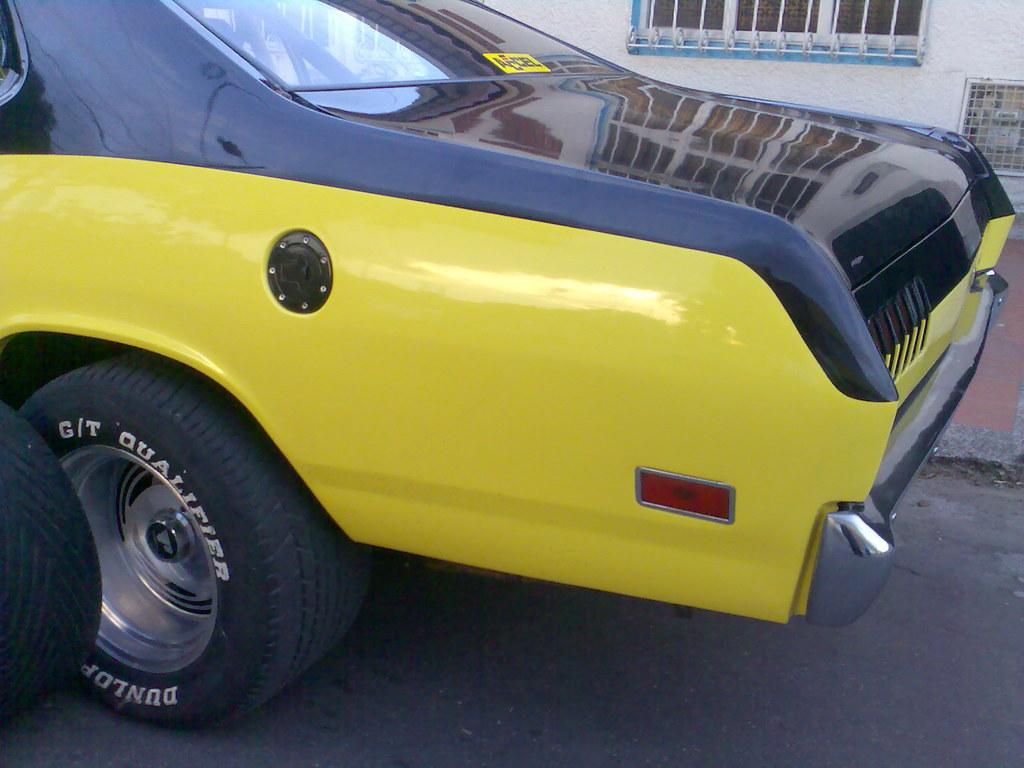What part of the car can be seen in the image? The back side part of the car is visible in the image. What colors are used for the car in the image? The car has a yellow and black color scheme. What type of surface is beside the car? There is a part of a path beside the car. What type of architectural feature can be seen in the image? There is a wall with a window in the image. What type of bomb can be seen in the image? A: There is no bomb present in the image. Can you tell me the price of the car from the receipt in the image? There is no receipt present in the image. 